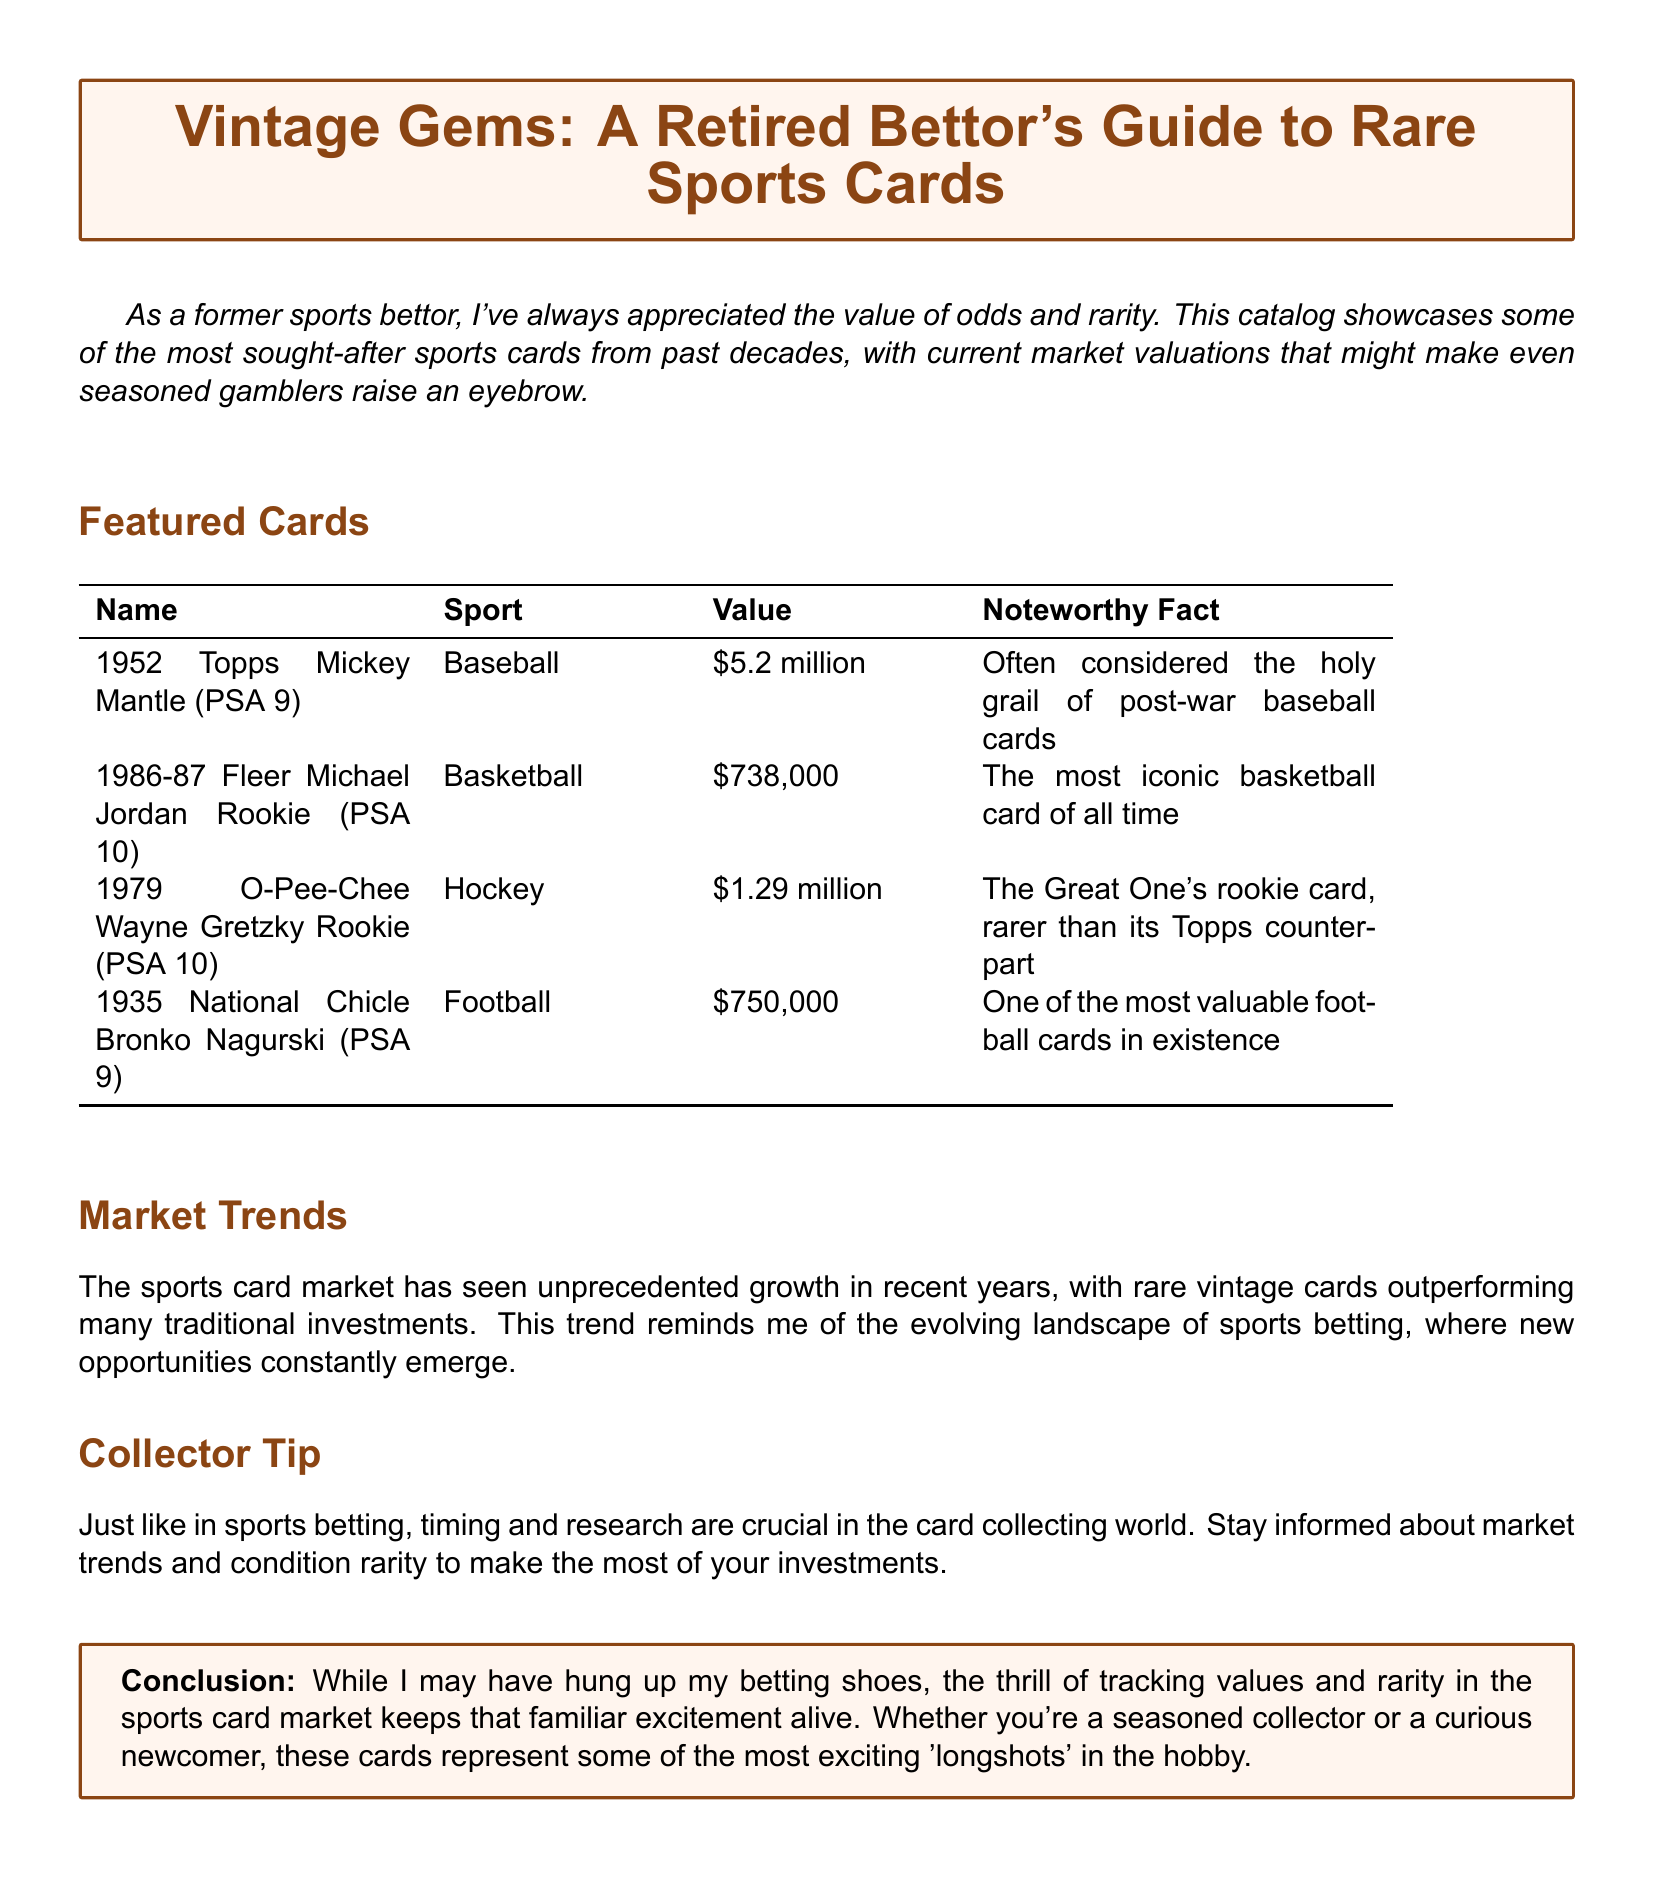What is the value of the 1952 Topps Mickey Mantle card? The document states the value of the 1952 Topps Mickey Mantle card as \$5.2 million.
Answer: \$5.2 million Who is featured on the 1986-87 Fleer rookie card? The document lists Michael Jordan as the player on the 1986-87 Fleer rookie card.
Answer: Michael Jordan What is the value of the Wayne Gretzky rookie card? According to the document, the value of the Wayne Gretzky rookie card is \$1.29 million.
Answer: \$1.29 million How many noteworthy facts are listed for the featured cards? The document includes one noteworthy fact for each of the four featured cards, totaling four noteworthy facts.
Answer: Four Which sport does the Bronko Nagurski card represent? The document indicates that the Bronko Nagurski card represents football.
Answer: Football What is the trend mentioned in the market trends section? The document mentions unprecedented growth in the sports card market.
Answer: Unprecedented growth What does the collector tip emphasize about timing? The collector tip emphasizes that timing is crucial in the card collecting world, similar to sports betting.
Answer: Timing Which card is considered the holy grail of post-war baseball cards? The document refers to the 1952 Topps Mickey Mantle card as the holy grail of post-war baseball cards.
Answer: 1952 Topps Mickey Mantle 